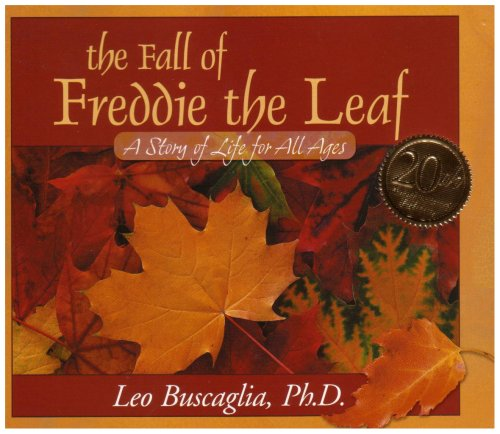What can we learn about life from the story of Freddie the Leaf? The story of Freddie the Leaf serves as a touching metaphor for the cycles of life, providing insights into acceptance, change, and letting go. It teaches that every phase of life, even the end, holds its own beauty and significance. 